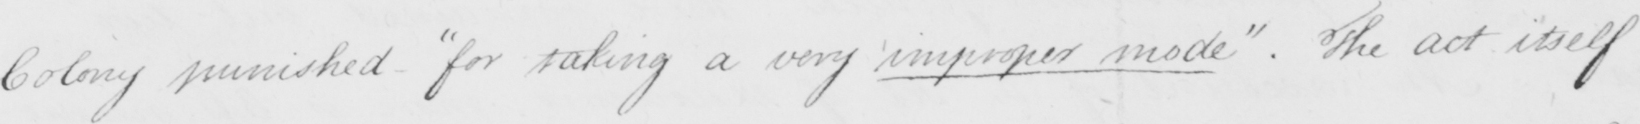Please transcribe the handwritten text in this image. Colony punished  " for taking a very improper mode "  . The act itself 